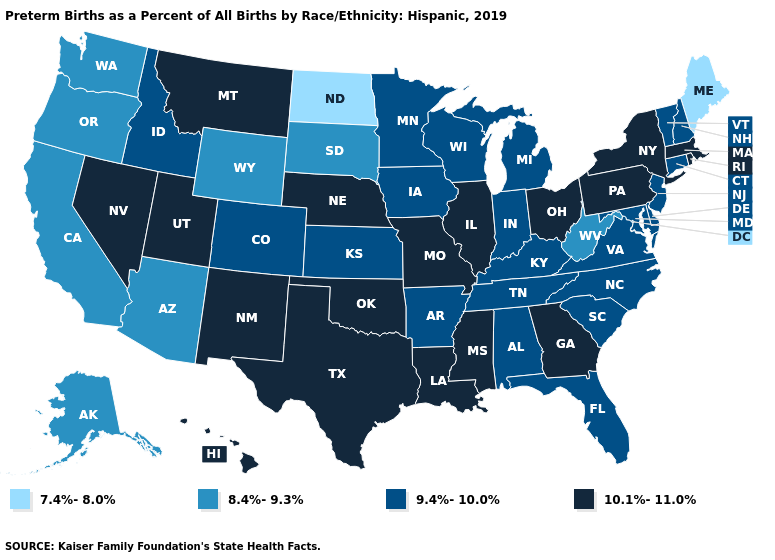Does Vermont have the lowest value in the USA?
Answer briefly. No. What is the value of South Carolina?
Quick response, please. 9.4%-10.0%. Among the states that border New York , which have the highest value?
Answer briefly. Massachusetts, Pennsylvania. Among the states that border Indiana , does Ohio have the lowest value?
Be succinct. No. Name the states that have a value in the range 9.4%-10.0%?
Quick response, please. Alabama, Arkansas, Colorado, Connecticut, Delaware, Florida, Idaho, Indiana, Iowa, Kansas, Kentucky, Maryland, Michigan, Minnesota, New Hampshire, New Jersey, North Carolina, South Carolina, Tennessee, Vermont, Virginia, Wisconsin. Name the states that have a value in the range 10.1%-11.0%?
Answer briefly. Georgia, Hawaii, Illinois, Louisiana, Massachusetts, Mississippi, Missouri, Montana, Nebraska, Nevada, New Mexico, New York, Ohio, Oklahoma, Pennsylvania, Rhode Island, Texas, Utah. Does the map have missing data?
Quick response, please. No. What is the value of Washington?
Keep it brief. 8.4%-9.3%. Does Kansas have the lowest value in the MidWest?
Answer briefly. No. Does North Dakota have the lowest value in the USA?
Quick response, please. Yes. Which states hav the highest value in the South?
Keep it brief. Georgia, Louisiana, Mississippi, Oklahoma, Texas. Does West Virginia have the highest value in the South?
Answer briefly. No. Does the map have missing data?
Concise answer only. No. Name the states that have a value in the range 7.4%-8.0%?
Keep it brief. Maine, North Dakota. 